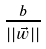Convert formula to latex. <formula><loc_0><loc_0><loc_500><loc_500>\frac { b } { | | \vec { w } | | }</formula> 